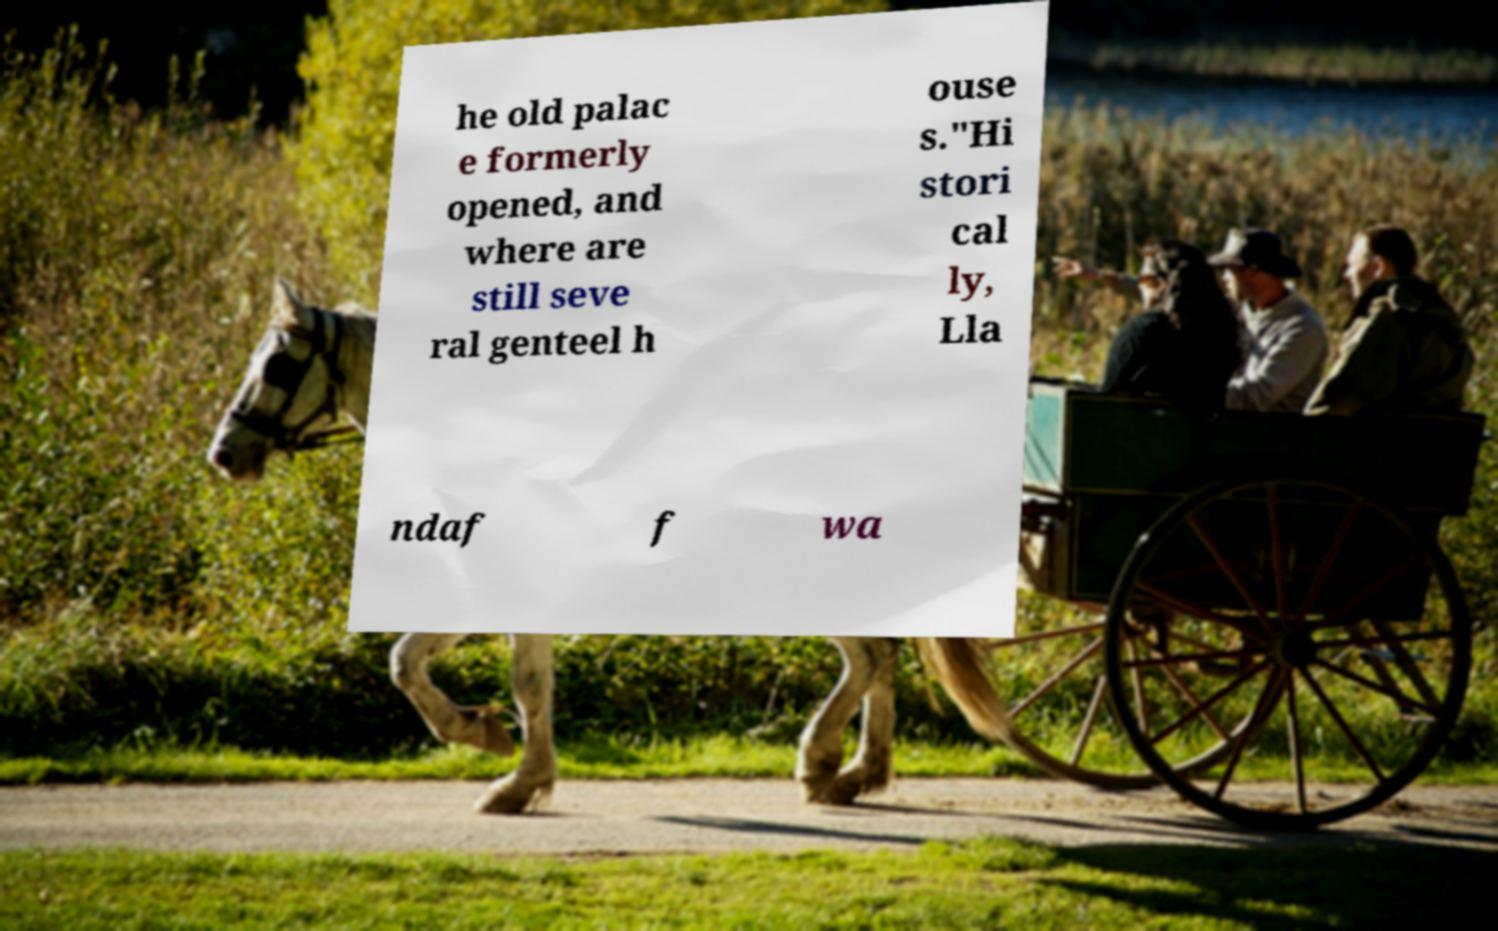Please read and relay the text visible in this image. What does it say? he old palac e formerly opened, and where are still seve ral genteel h ouse s."Hi stori cal ly, Lla ndaf f wa 